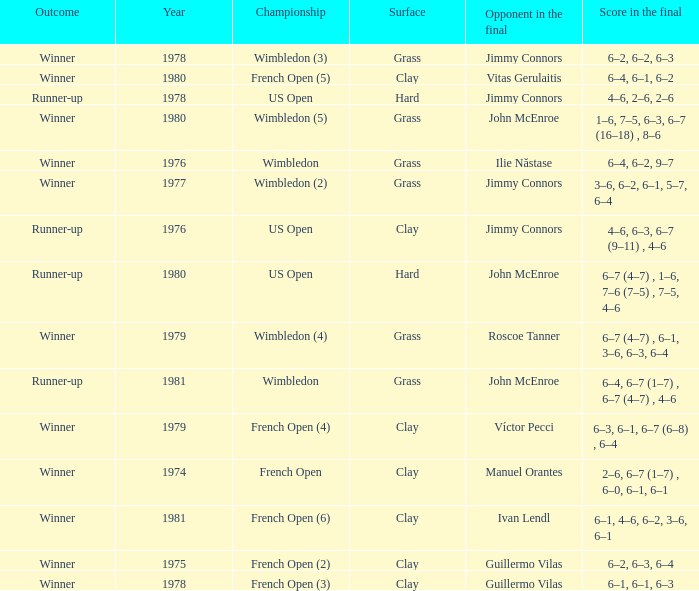What is every score in the final for opponent in final John Mcenroe at US Open? 6–7 (4–7) , 1–6, 7–6 (7–5) , 7–5, 4–6. 